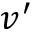Convert formula to latex. <formula><loc_0><loc_0><loc_500><loc_500>v ^ { \prime }</formula> 